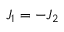Convert formula to latex. <formula><loc_0><loc_0><loc_500><loc_500>J _ { 1 } = - J _ { 2 }</formula> 